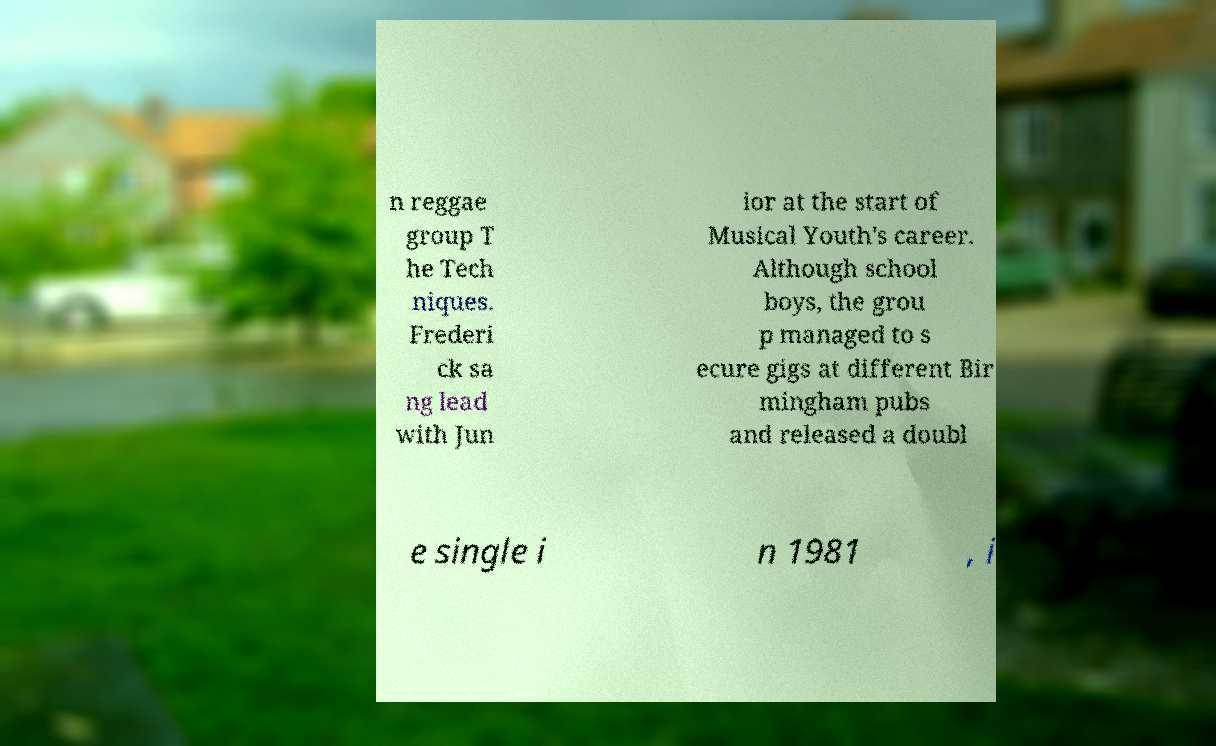There's text embedded in this image that I need extracted. Can you transcribe it verbatim? n reggae group T he Tech niques. Frederi ck sa ng lead with Jun ior at the start of Musical Youth's career. Although school boys, the grou p managed to s ecure gigs at different Bir mingham pubs and released a doubl e single i n 1981 , i 